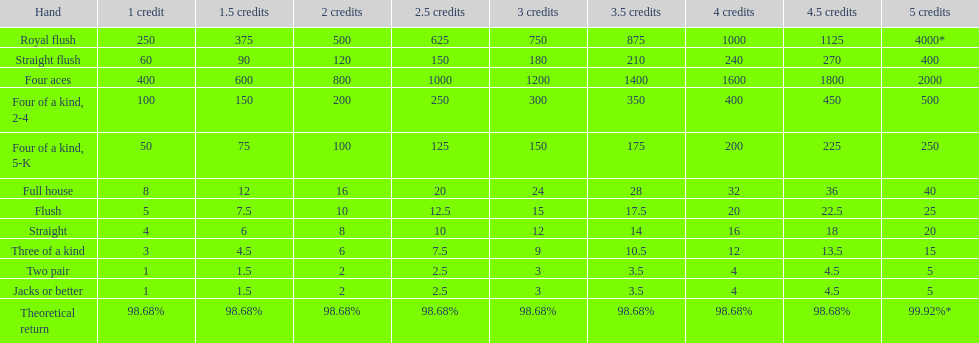Which hand is the third best hand in the card game super aces? Four aces. Which hand is the second best hand? Straight flush. Which hand had is the best hand? Royal flush. 